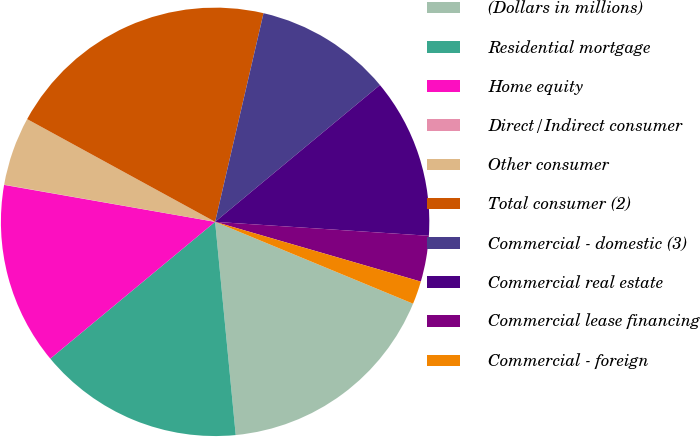<chart> <loc_0><loc_0><loc_500><loc_500><pie_chart><fcel>(Dollars in millions)<fcel>Residential mortgage<fcel>Home equity<fcel>Direct/Indirect consumer<fcel>Other consumer<fcel>Total consumer (2)<fcel>Commercial - domestic (3)<fcel>Commercial real estate<fcel>Commercial lease financing<fcel>Commercial - foreign<nl><fcel>17.22%<fcel>15.5%<fcel>13.78%<fcel>0.02%<fcel>5.18%<fcel>20.66%<fcel>10.34%<fcel>12.06%<fcel>3.46%<fcel>1.74%<nl></chart> 